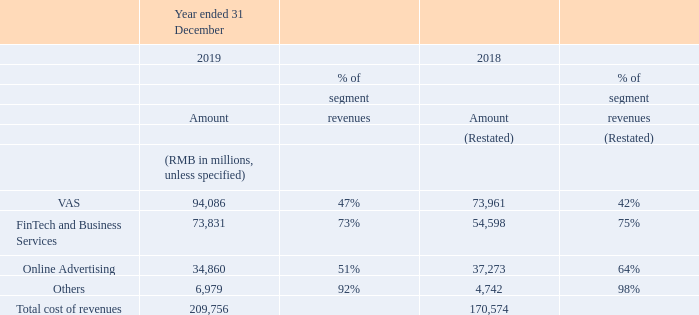Cost of revenues. Cost of revenues increased by 23% year-on-year to RMB209.8 billion. The increase primarily reflected greater content costs, costs of FinTech services and channel costs. As a percentage of revenues, cost of revenues increased to 56% for the year ended 31 December 2019 from 55% for the year ended 31 December 2018. The following table sets forth our cost of revenues by line of business for the years ended 31 December 2019 and 2018:
Cost of revenues for VAS increased by 27% year-on-year to RMB94,086 million. The increase was mainly due to greater content costs for services and products such as live broadcast services, online games and video streaming subscriptions, as well as channel costs for smart phone games.
Cost of revenues for FinTech and Business Services increased by 35% year-on-year to RMB73,831 million. The increase primarily reflected greater costs of payment-related and cloud services due to the enhanced scale of our payment and cloud activities.
Cost of revenues for Online Advertising decreased by 6% year-on-year to RMB34,860 million. The decrease was mainly driven by lower content costs for our advertising-funded long form video service resulting from fewer content releases and improved cost efficiency, partly offset by other cost items.
What was the year-on-year change in cost of revenues for VAS? 27%. What was the year-on-year change in cost of revenues for FinTech and Business Services? 35%. What was the year-on-year change in cost of revenues for Online Advertising? 6%. How much did the total cost of revenues increase by from 2018 to 2019?
Answer scale should be: million. 209,756-170,574
Answer: 39182. How much is the combined 2019 cost of revenues for VAS and Fintech and Business Services?
Answer scale should be: million. 94,086+73,831
Answer: 167917. How much is the combined 2019 cost of revenues for Online Advertising and Others?
Answer scale should be: million. 34,860+6,979
Answer: 41839. 